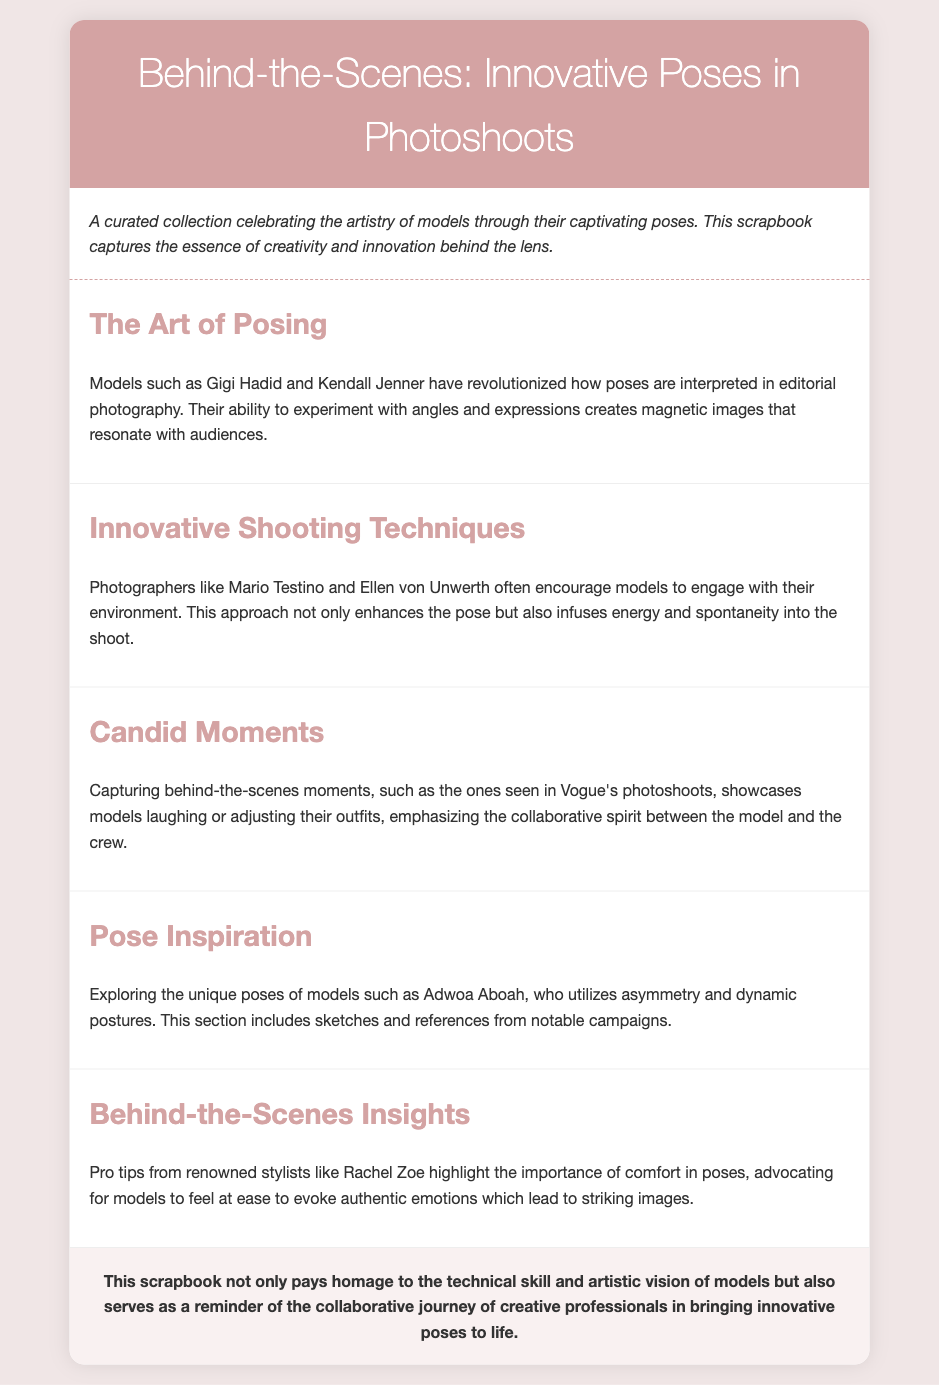what is the title of the scrapbook? The title of the scrapbook is found in the header section of the document, which clearly states its name.
Answer: Behind-the-Scenes: Innovative Poses in Photoshoots who are two models mentioned for their innovative posing? The document lists specific models noted for their posing techniques.
Answer: Gigi Hadid and Kendall Jenner which photographers are known for encouraging engagement with the environment? The section about innovative shooting techniques includes names of notable photographers who have this approach.
Answer: Mario Testino and Ellen von Unwerth what unique posing technique does Adwoa Aboah utilize? Within the Pose Inspiration section, a specific technique used by one of the models is highlighted.
Answer: Asymmetry and dynamic postures what is the importance of comfort in poses as mentioned in the document? The document discusses the advice from stylists about posing, particularly emphasizing a key aspect that improves the outcome.
Answer: Evoke authentic emotions 